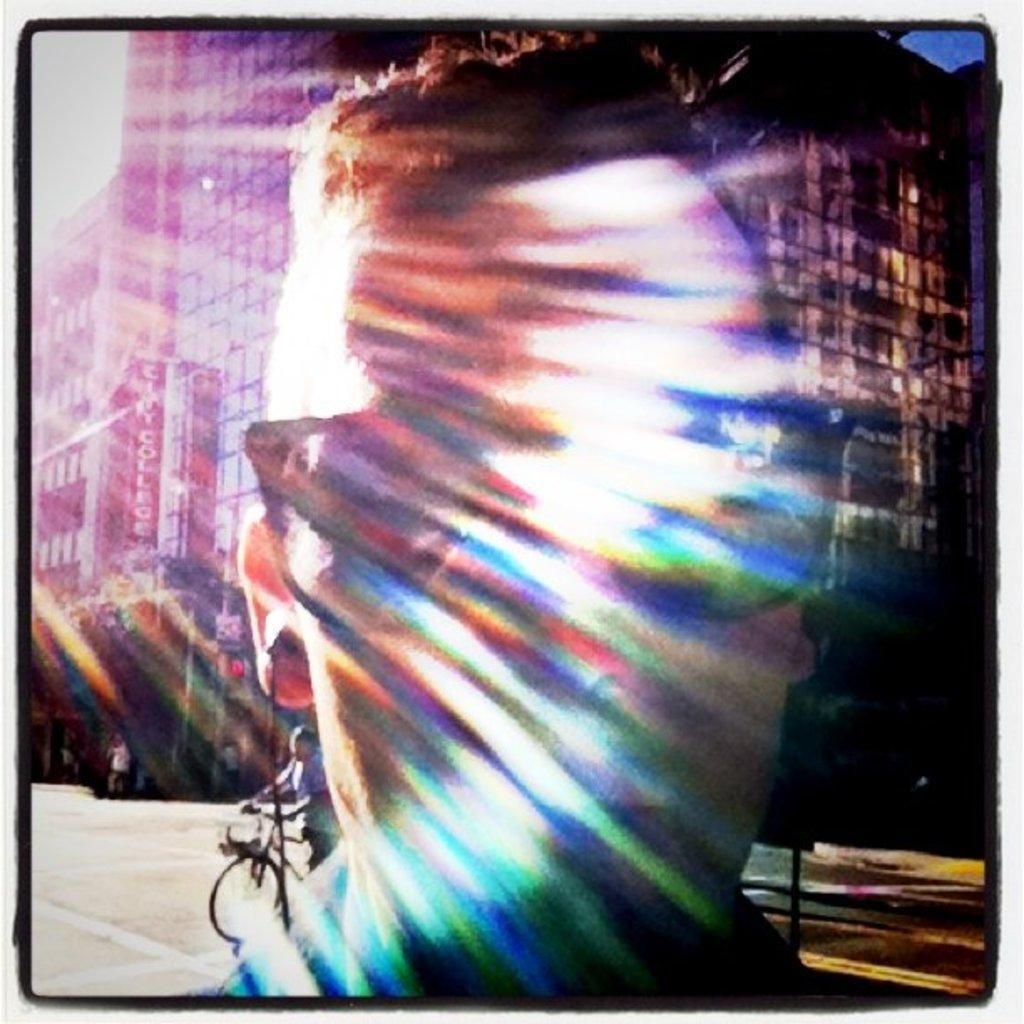How would you summarize this image in a sentence or two? This is an edited image. In the foreground of the picture there is a person's face. In the center of the picture there is a person with bicycle. In the background there are buildings, signal and other objects. Sky is sunny. 